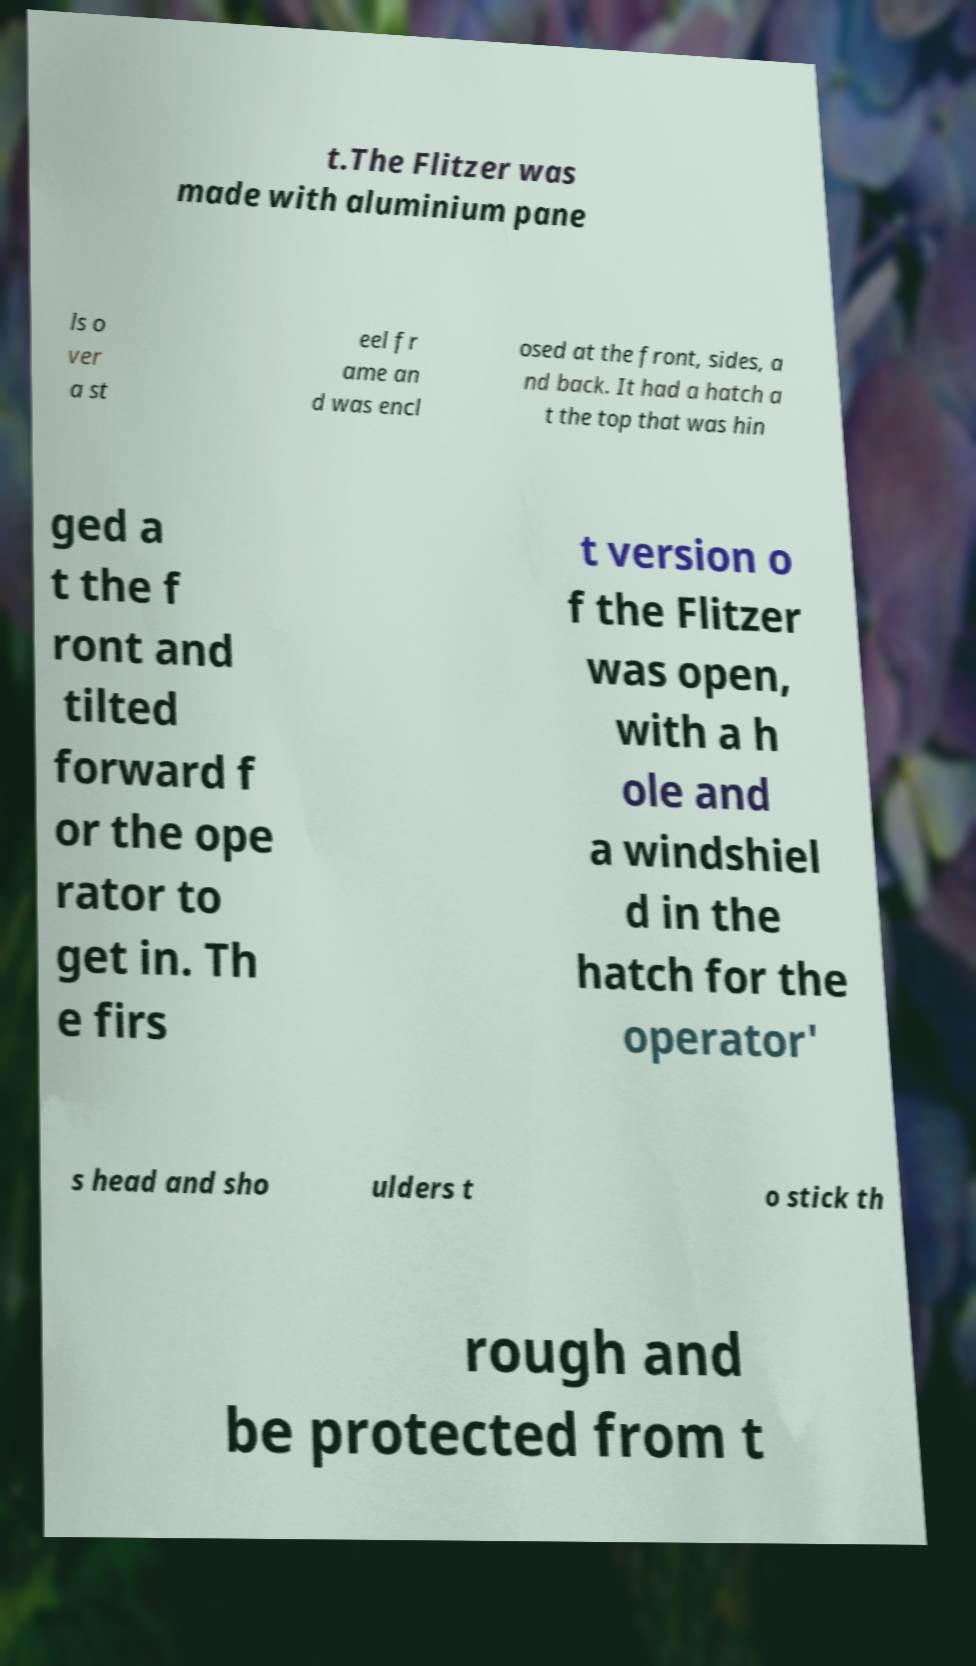Please read and relay the text visible in this image. What does it say? t.The Flitzer was made with aluminium pane ls o ver a st eel fr ame an d was encl osed at the front, sides, a nd back. It had a hatch a t the top that was hin ged a t the f ront and tilted forward f or the ope rator to get in. Th e firs t version o f the Flitzer was open, with a h ole and a windshiel d in the hatch for the operator' s head and sho ulders t o stick th rough and be protected from t 